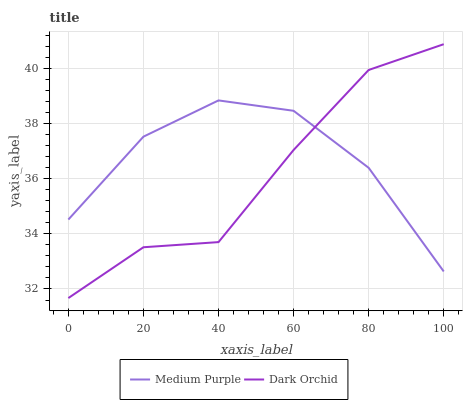Does Dark Orchid have the minimum area under the curve?
Answer yes or no. Yes. Does Medium Purple have the maximum area under the curve?
Answer yes or no. Yes. Does Dark Orchid have the maximum area under the curve?
Answer yes or no. No. Is Medium Purple the smoothest?
Answer yes or no. Yes. Is Dark Orchid the roughest?
Answer yes or no. Yes. Is Dark Orchid the smoothest?
Answer yes or no. No. Does Dark Orchid have the lowest value?
Answer yes or no. Yes. Does Dark Orchid have the highest value?
Answer yes or no. Yes. Does Medium Purple intersect Dark Orchid?
Answer yes or no. Yes. Is Medium Purple less than Dark Orchid?
Answer yes or no. No. Is Medium Purple greater than Dark Orchid?
Answer yes or no. No. 